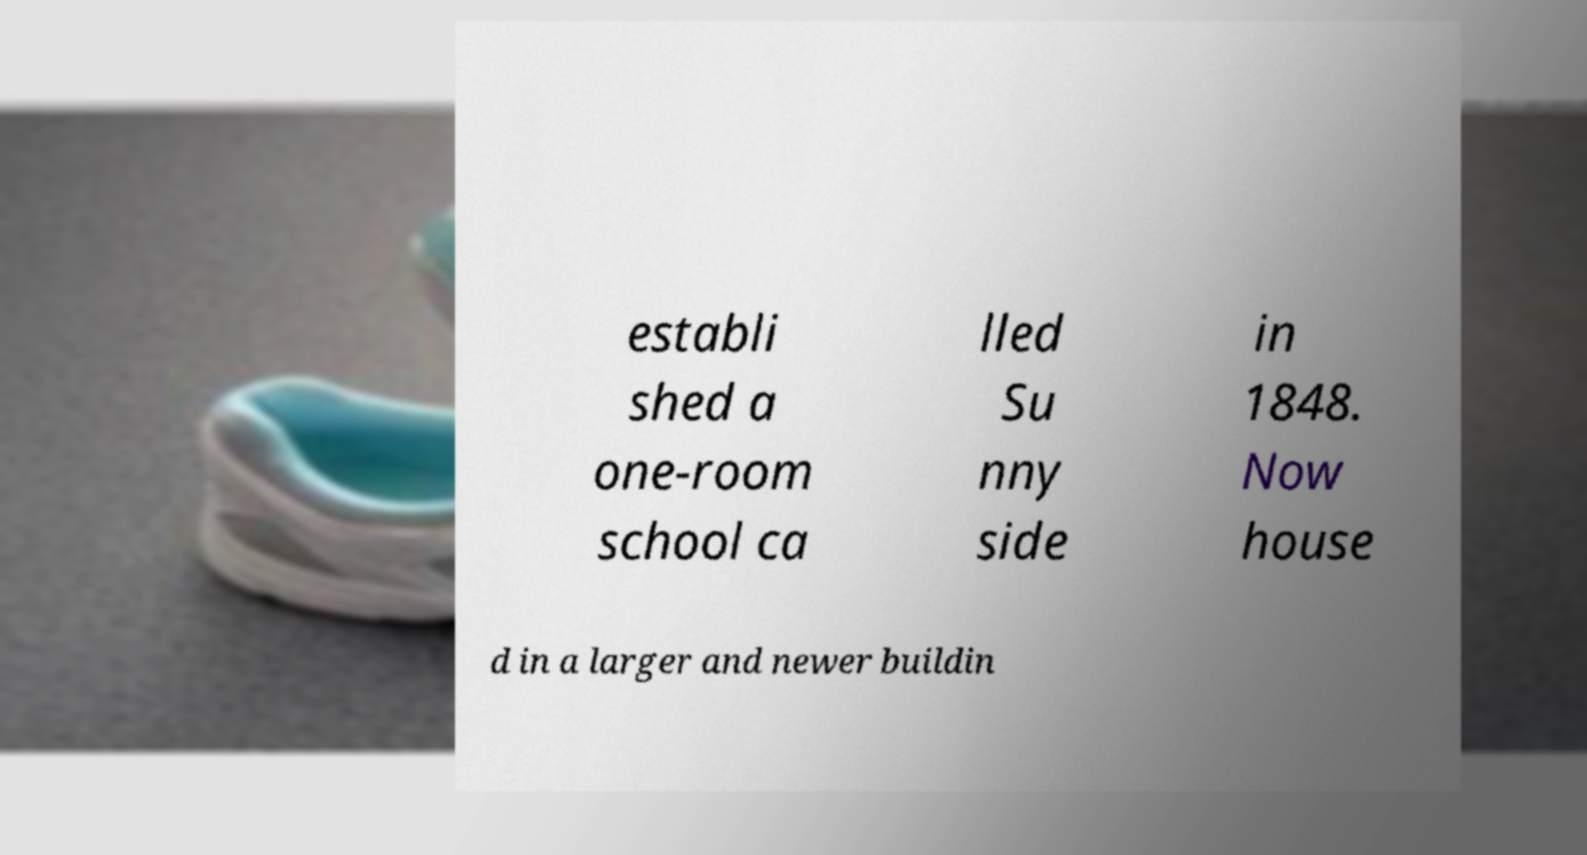Please read and relay the text visible in this image. What does it say? establi shed a one-room school ca lled Su nny side in 1848. Now house d in a larger and newer buildin 